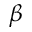<formula> <loc_0><loc_0><loc_500><loc_500>\beta</formula> 